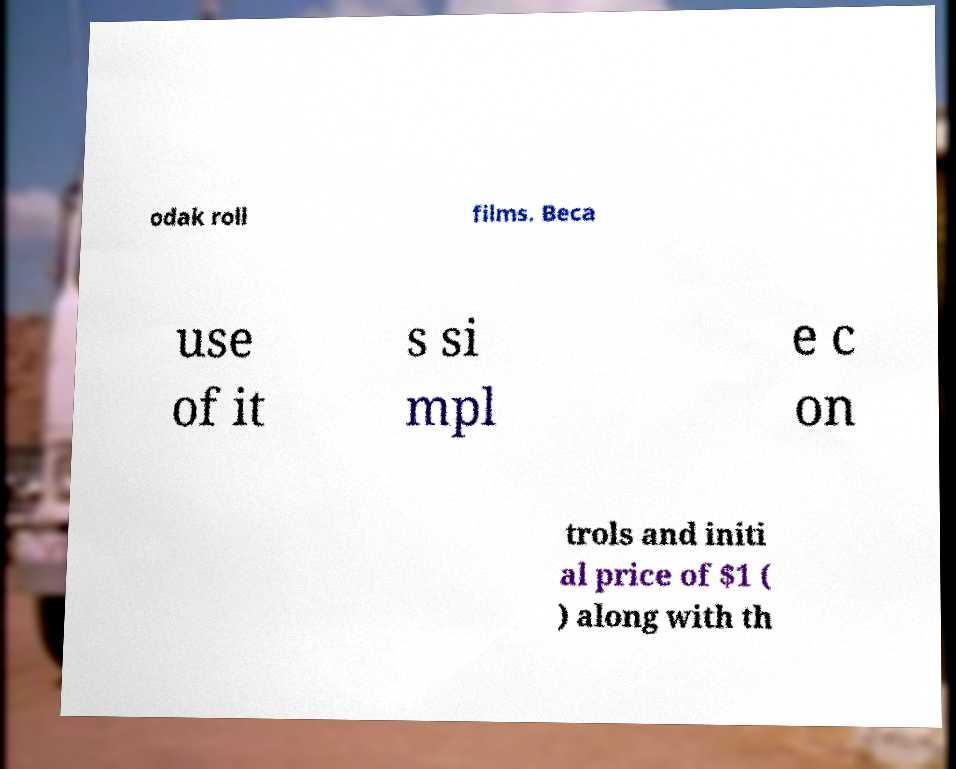Can you accurately transcribe the text from the provided image for me? odak roll films. Beca use of it s si mpl e c on trols and initi al price of $1 ( ) along with th 